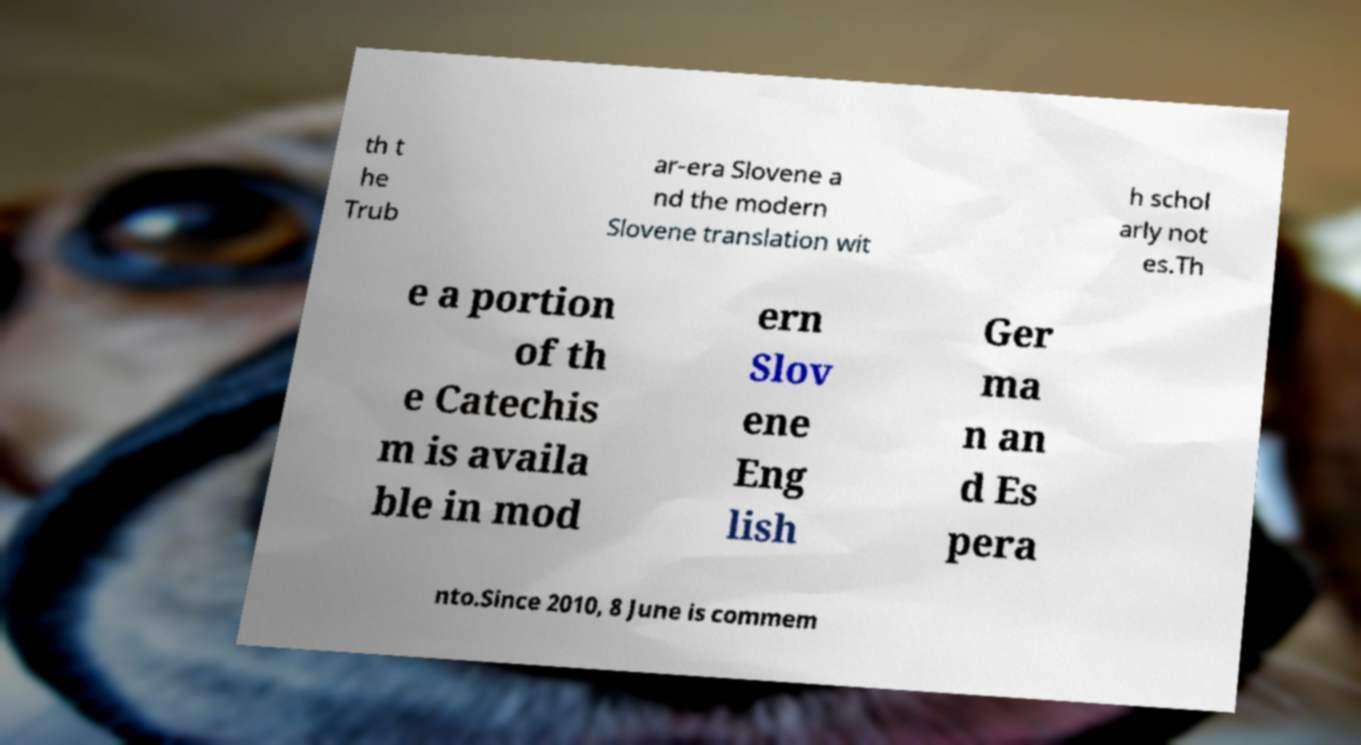Could you extract and type out the text from this image? th t he Trub ar-era Slovene a nd the modern Slovene translation wit h schol arly not es.Th e a portion of th e Catechis m is availa ble in mod ern Slov ene Eng lish Ger ma n an d Es pera nto.Since 2010, 8 June is commem 